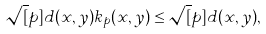Convert formula to latex. <formula><loc_0><loc_0><loc_500><loc_500>\sqrt { [ } p ] { d ( x , y ) } k _ { p } ( x , y ) \leq \sqrt { [ } p ] { d ( x , y ) } ,</formula> 